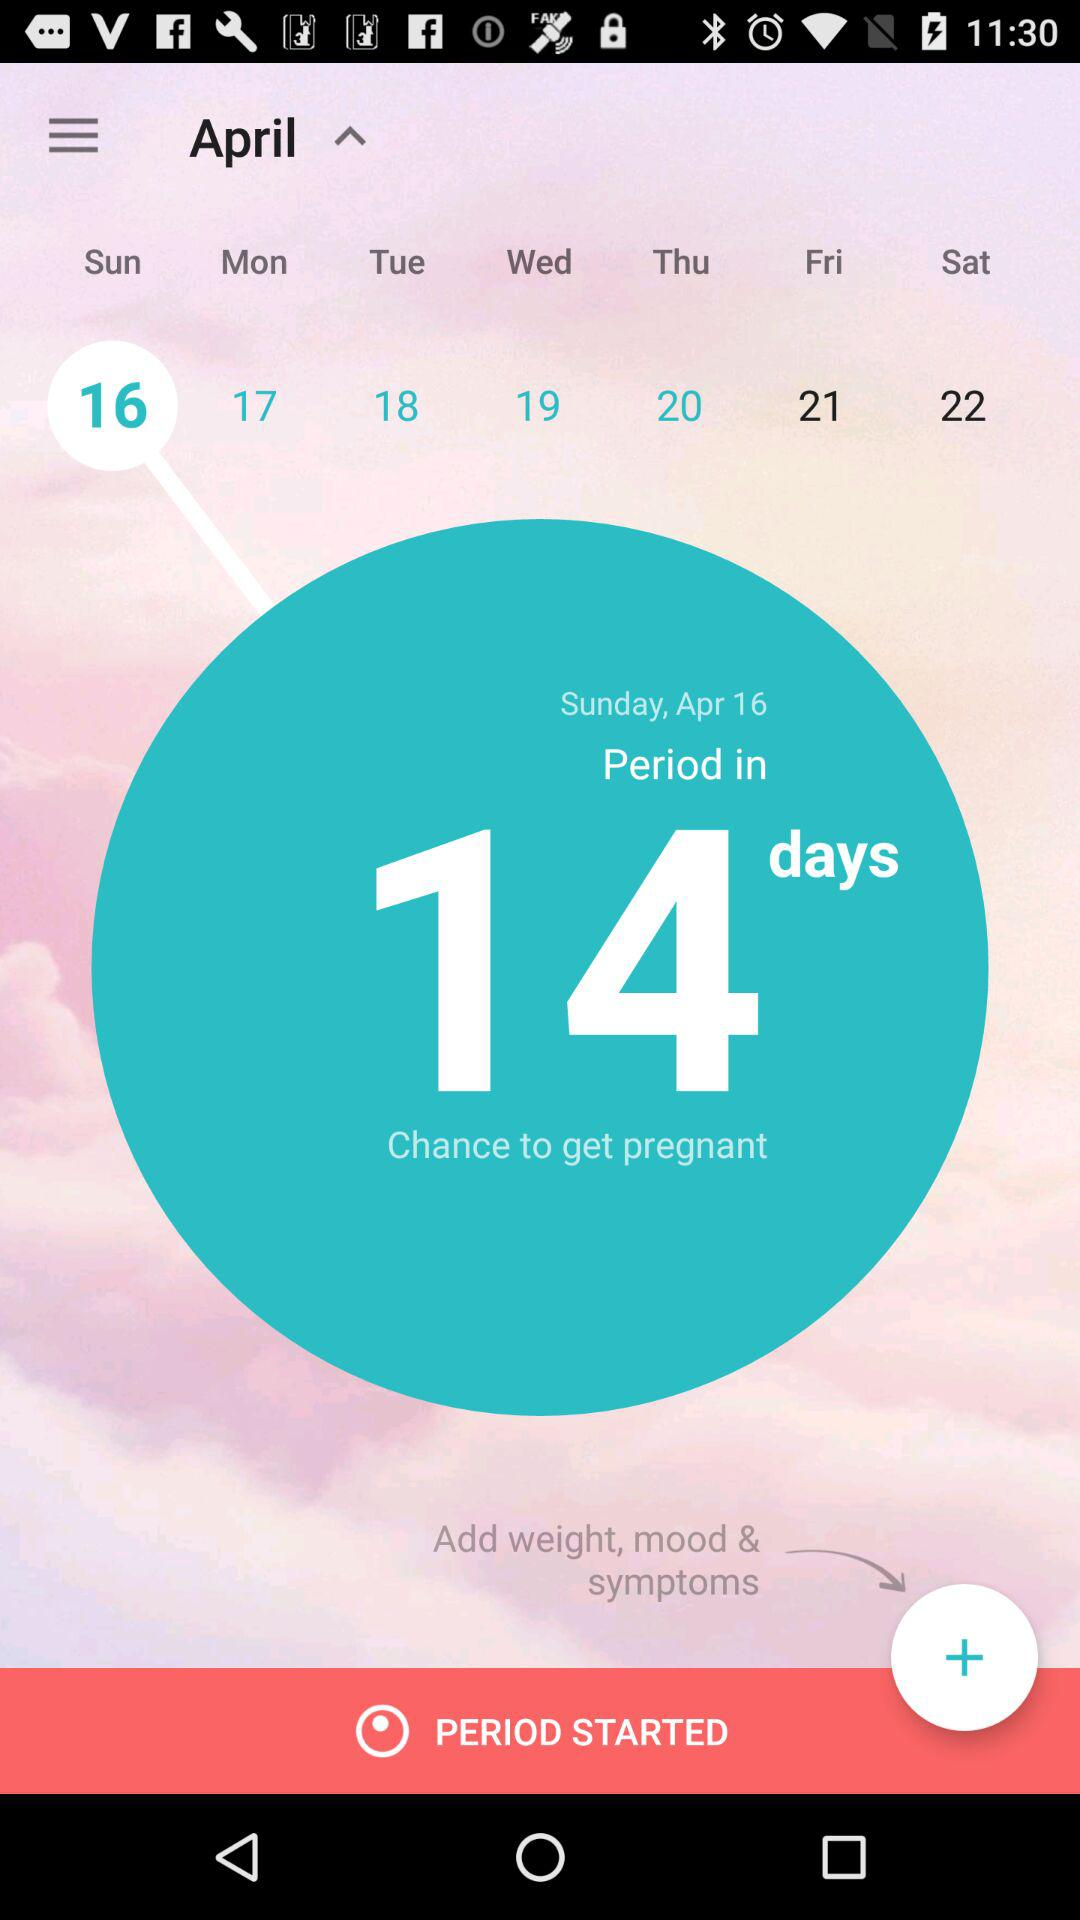Which things can we add in the application? You can add weight, mood and symptoms in the application. 